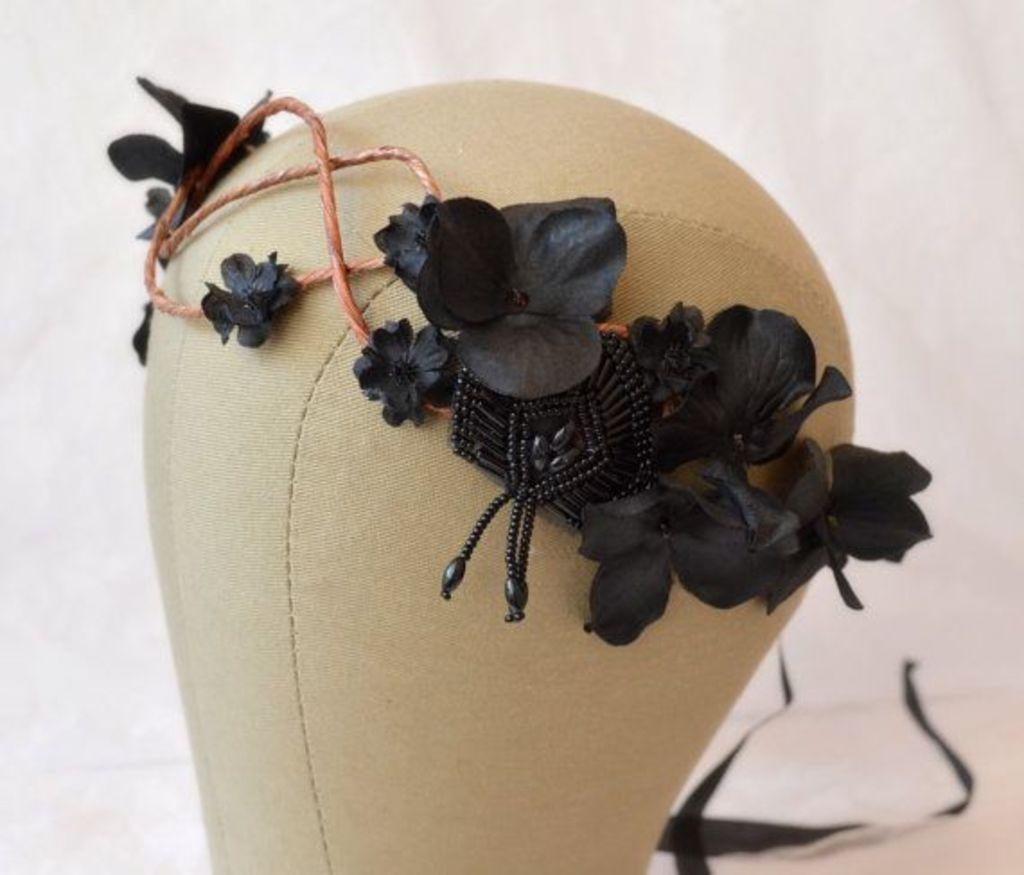What are the black color things with threads in the image? The black color things with threads are placed on an object. Can you describe the object they are placed on? Unfortunately, the facts provided do not give enough information to describe the object. What can be seen in the background of the image? There are black ribbons and white color present in the background of the image. What type of grape is being squeezed by the hose in the image? There is no hose or grape present in the image. What is the sponge used for in the image? There is no sponge present in the image. 